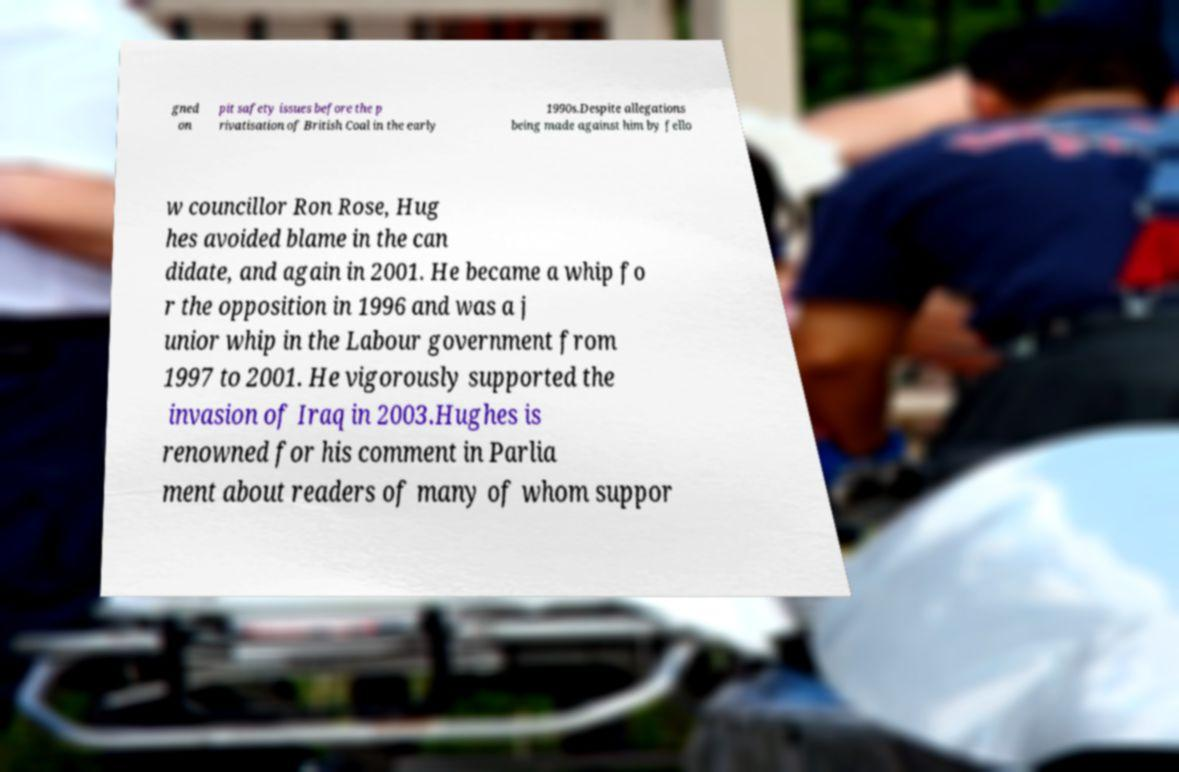Can you read and provide the text displayed in the image?This photo seems to have some interesting text. Can you extract and type it out for me? gned on pit safety issues before the p rivatisation of British Coal in the early 1990s.Despite allegations being made against him by fello w councillor Ron Rose, Hug hes avoided blame in the can didate, and again in 2001. He became a whip fo r the opposition in 1996 and was a j unior whip in the Labour government from 1997 to 2001. He vigorously supported the invasion of Iraq in 2003.Hughes is renowned for his comment in Parlia ment about readers of many of whom suppor 